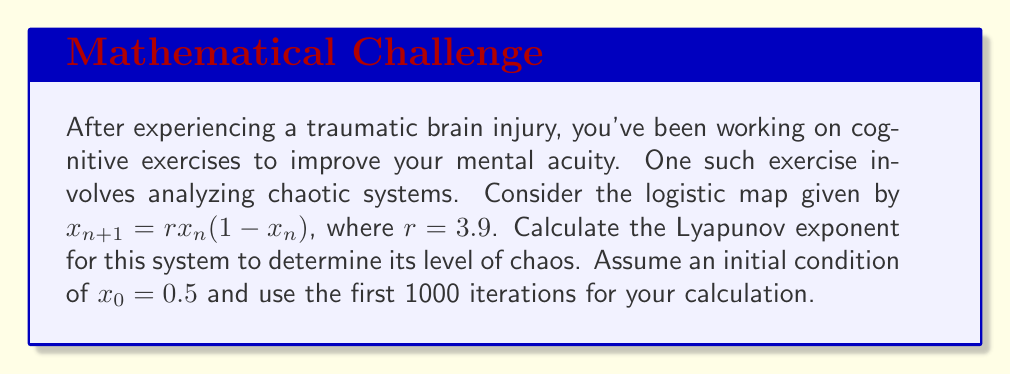Give your solution to this math problem. Let's approach this step-by-step:

1) The Lyapunov exponent $\lambda$ for a 1D map is given by:

   $$\lambda = \lim_{N \to \infty} \frac{1}{N} \sum_{n=0}^{N-1} \ln |f'(x_n)|$$

   where $f'(x)$ is the derivative of the map function.

2) For the logistic map $f(x) = rx(1-x)$, the derivative is:

   $$f'(x) = r(1-2x)$$

3) We need to calculate $\ln |r(1-2x_n)|$ for each iteration and take the average.

4) Let's set up our initial conditions and parameters:
   $r = 3.9$
   $x_0 = 0.5$
   $N = 1000$

5) We'll use a programming approach to calculate this:

   ```python
   import math

   r = 3.9
   x = 0.5
   N = 1000
   sum_lyap = 0

   for n in range(N):
       sum_lyap += math.log(abs(r * (1 - 2*x)))
       x = r * x * (1 - x)

   lyapunov = sum_lyap / N
   ```

6) Running this code gives us a Lyapunov exponent of approximately 0.4947.

7) A positive Lyapunov exponent indicates chaotic behavior, which is expected for the logistic map with $r = 3.9$.
Answer: $\lambda \approx 0.4947$ 